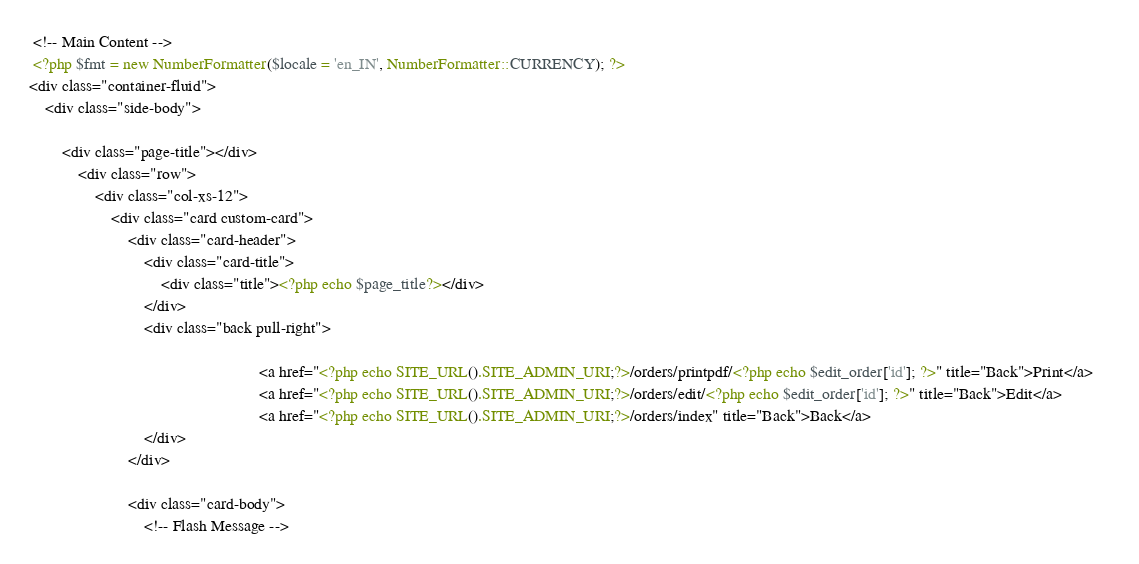Convert code to text. <code><loc_0><loc_0><loc_500><loc_500><_PHP_> <!-- Main Content -->
 <?php $fmt = new NumberFormatter($locale = 'en_IN', NumberFormatter::CURRENCY); ?>
<div class="container-fluid">
    <div class="side-body">

		<div class="page-title"></div>
			<div class="row">
				<div class="col-xs-12">
					<div class="card custom-card">
						<div class="card-header">
							<div class="card-title">
								<div class="title"><?php echo $page_title?></div>
							</div>
							<div class="back pull-right"> 
                                                            
                                                        <a href="<?php echo SITE_URL().SITE_ADMIN_URI;?>/orders/printpdf/<?php echo $edit_order['id']; ?>" title="Back">Print</a>    
                                                        <a href="<?php echo SITE_URL().SITE_ADMIN_URI;?>/orders/edit/<?php echo $edit_order['id']; ?>" title="Back">Edit</a>
                                                        <a href="<?php echo SITE_URL().SITE_ADMIN_URI;?>/orders/index" title="Back">Back</a>
							</div>
						</div>
						
                   		<div class="card-body">
                    		<!-- Flash Message --></code> 